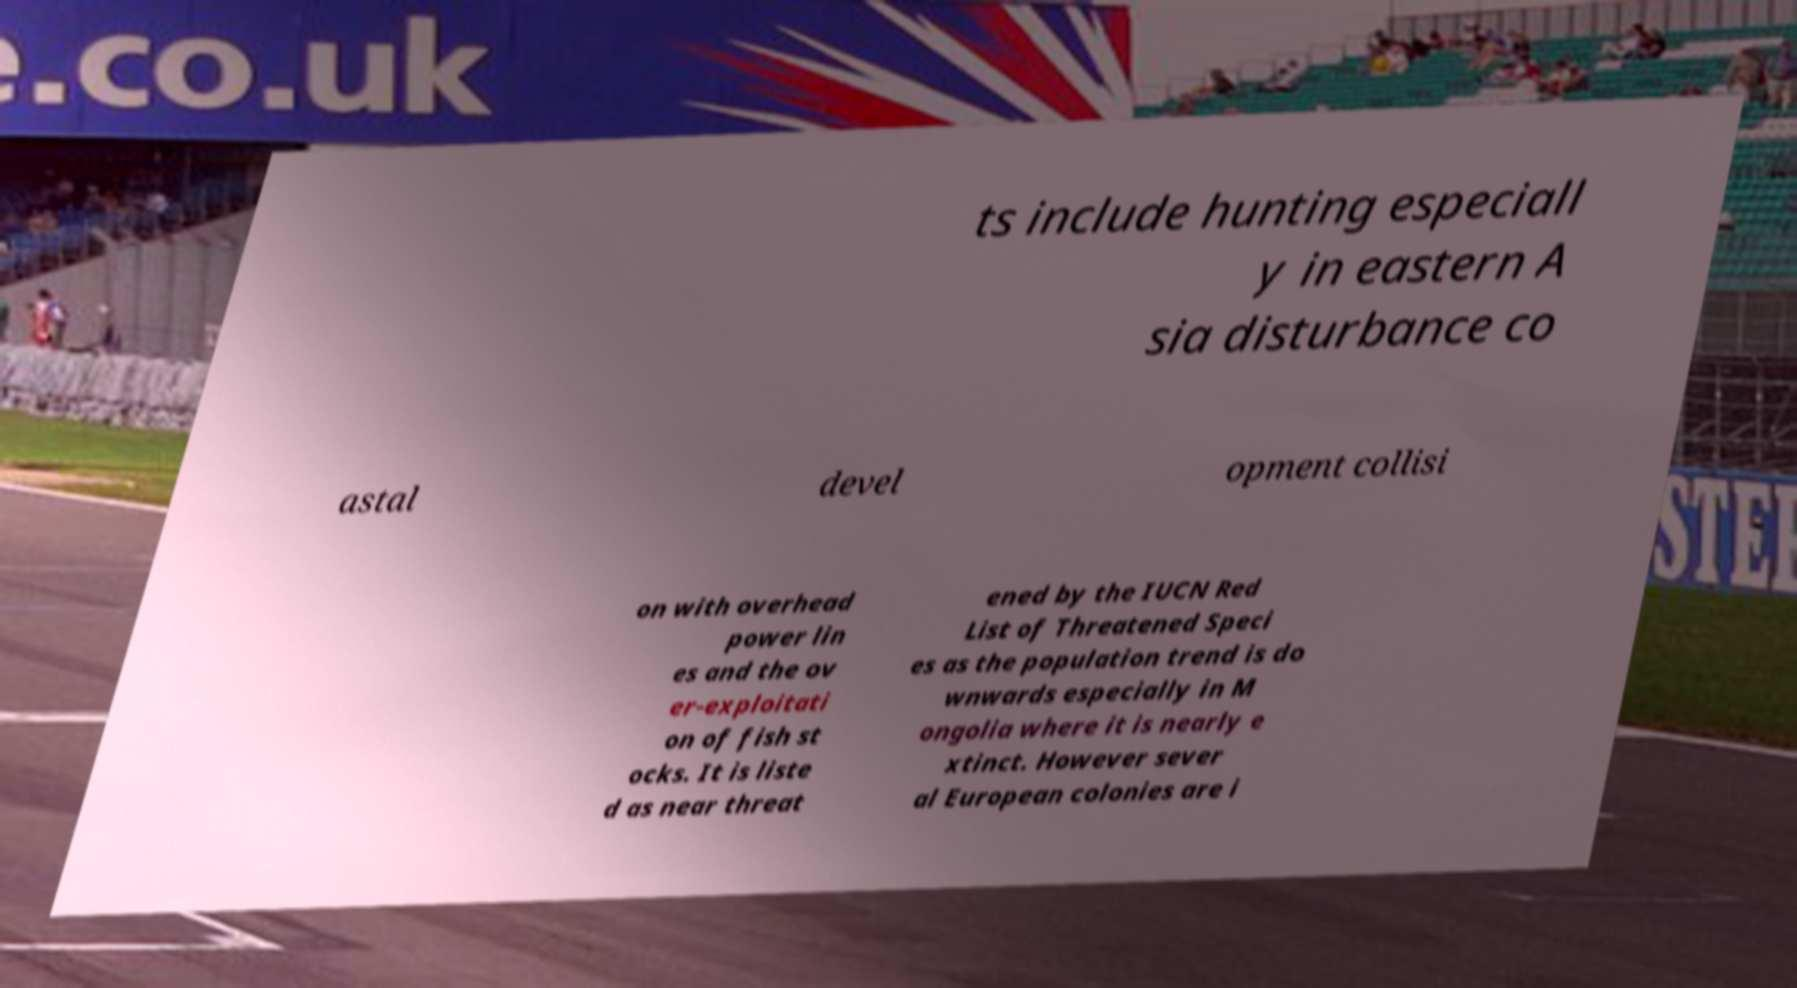Please identify and transcribe the text found in this image. ts include hunting especiall y in eastern A sia disturbance co astal devel opment collisi on with overhead power lin es and the ov er-exploitati on of fish st ocks. It is liste d as near threat ened by the IUCN Red List of Threatened Speci es as the population trend is do wnwards especially in M ongolia where it is nearly e xtinct. However sever al European colonies are i 